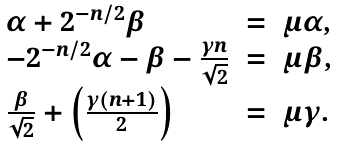Convert formula to latex. <formula><loc_0><loc_0><loc_500><loc_500>\begin{array} { l c l } \alpha + 2 ^ { - n / 2 } { \beta } & = & { \mu } { \alpha } , \\ - 2 ^ { - n / 2 } { \alpha } - { \beta } - \frac { { \gamma } n } { \sqrt { 2 } } & = & { \mu } { \beta } , \\ \frac { \beta } { \sqrt { 2 } } + \left ( \frac { { \gamma } ( n + 1 ) } { 2 } \right ) & = & { \mu } { \gamma } . \end{array}</formula> 